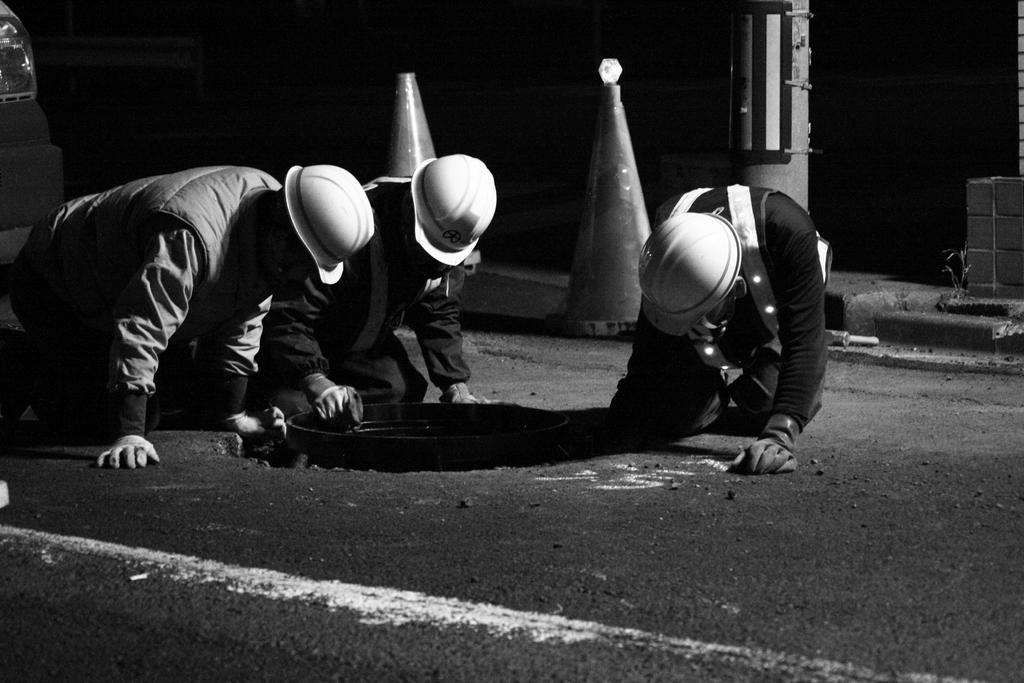How many people are present in the image? There are three people in the image. What are the people doing in the image? The people are kneeling on the ground. What objects can be seen in the image besides the people? There are two objects in the shape of cones in the image. What is the color scheme of the image? The image is black and white. What type of behavior is the man exhibiting in the image? There is no man present in the image; there are three people, and their gender is not specified. Additionally, the question focuses on behavior, which is not mentioned in the provided facts. 